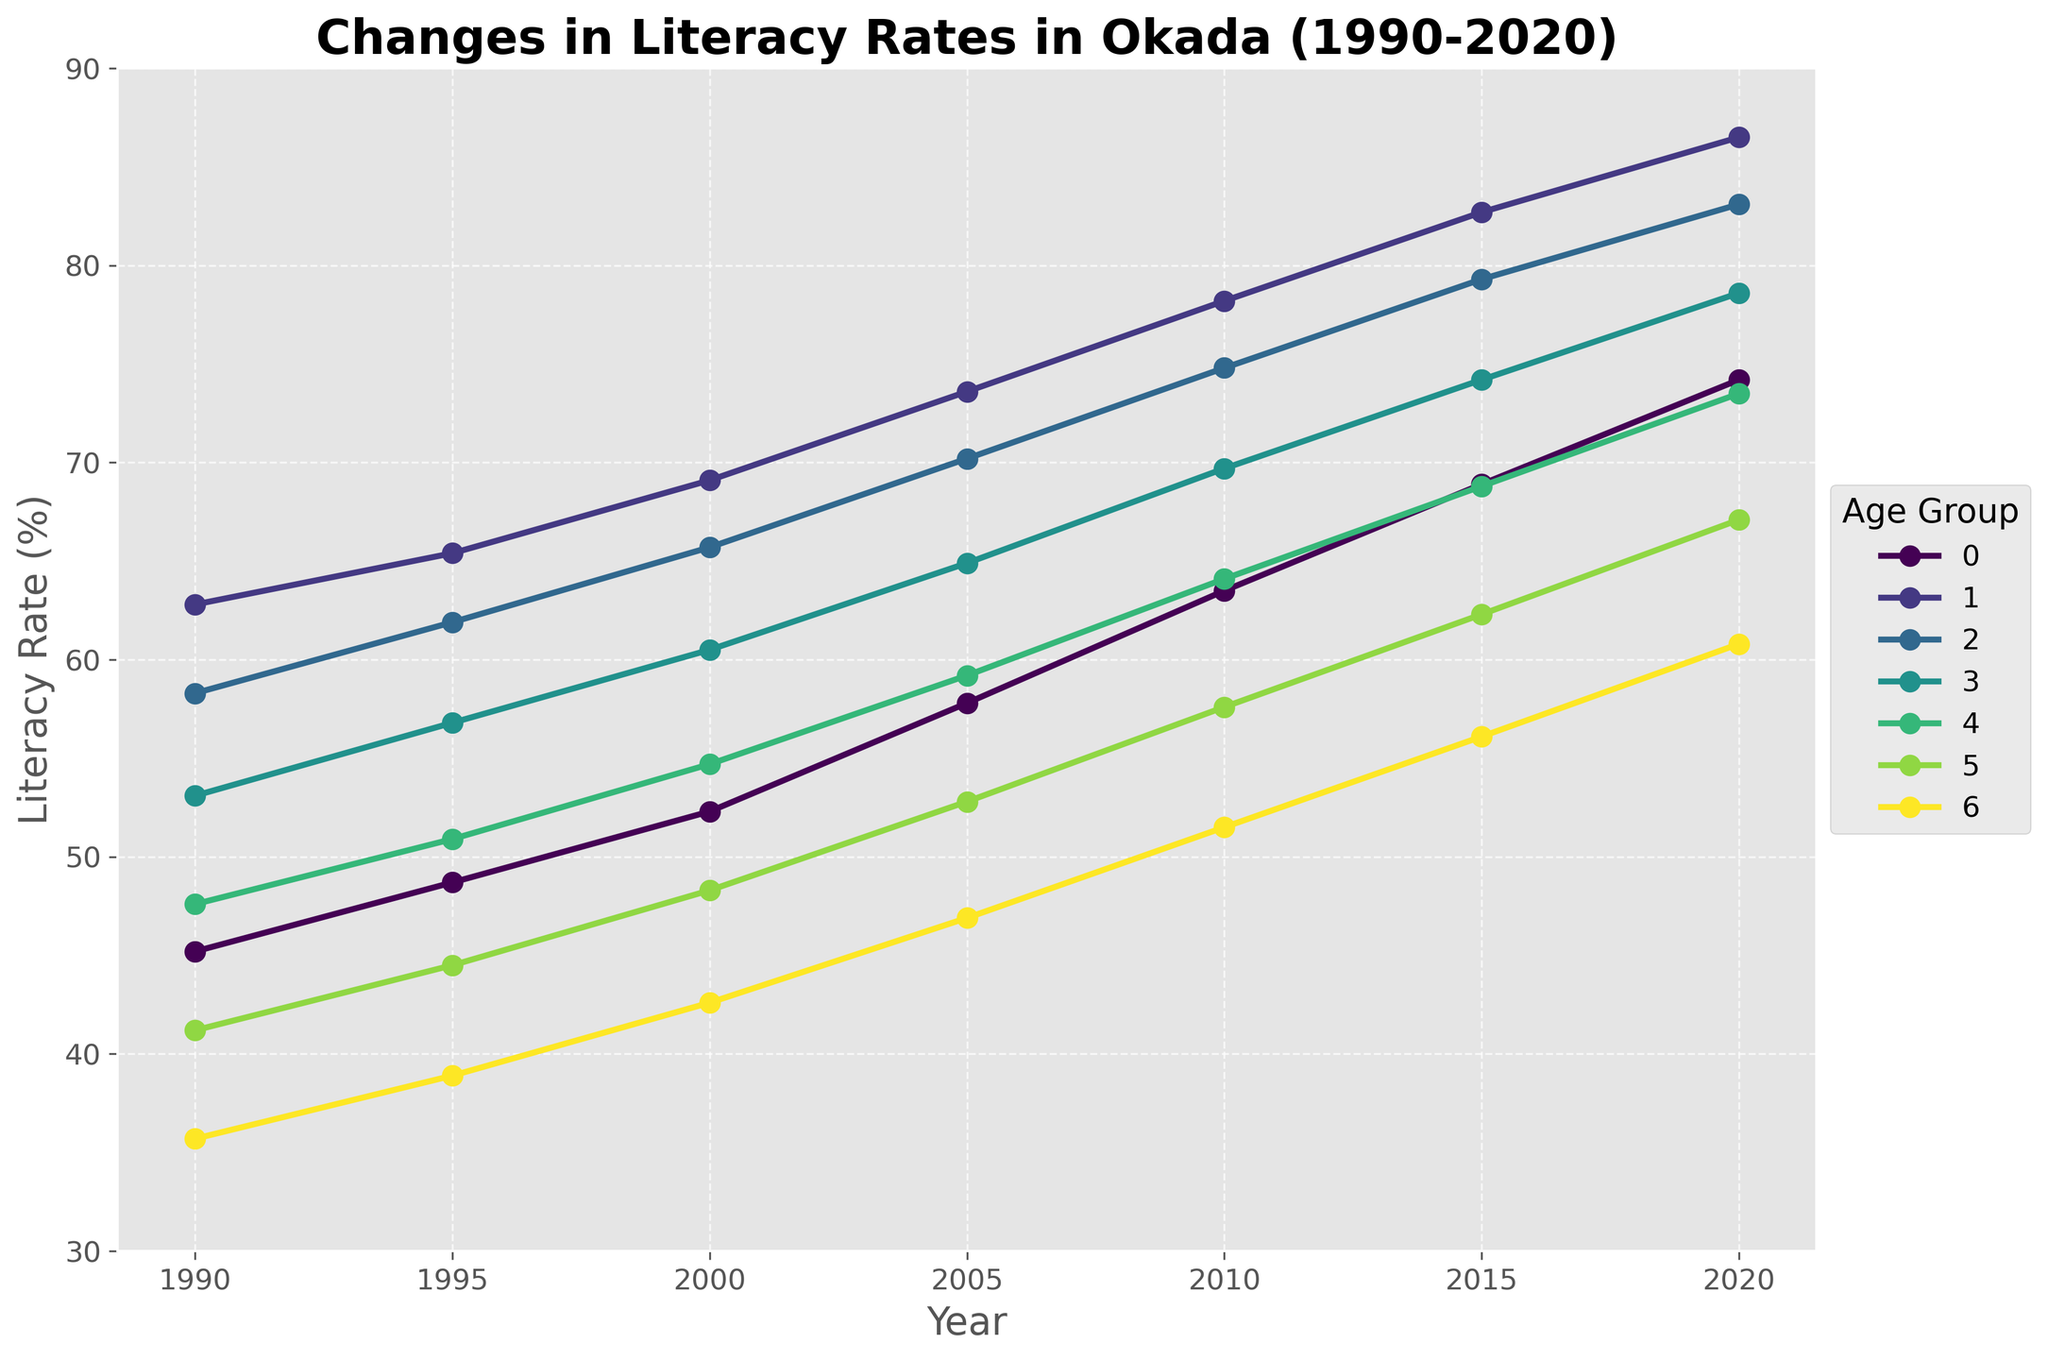What age group had the highest literacy rate in 2020? By looking at the data points for 2020, one can see that the age group 15-24 years has the highest literacy rate value compared to other age groups.
Answer: 15-24 years Which age group saw the largest increase in literacy rate from 1990 to 2020? To find the largest increase, subtract the 1990 value from the 2020 value for each age group and compare the differences. The age group 5-14 years had the largest increase (74.2 - 45.2 = 29).
Answer: 5-14 years What was the average literacy rate for the age group 25-34 years over the indicated years? Sum the literacy rates for the 25-34 years age group over all the years and divide by the number of years: (58.3 + 61.9 + 65.7 + 70.2 + 74.8 + 79.3 + 83.1) / 7 = 70.47.
Answer: 70.47 How does the literacy rate of the 65+ age group in 2000 compare to the 55-64 age group in 2000? Refer to the 2000 values; the literacy rate for 65+ years is 42.6, while for 55-64 years it is 48.3. This indicates that the 55-64 age group had a higher literacy rate in 2000.
Answer: The 55-64 age group had a higher rate By how much did the literacy rate for the 35-44 years age group increase from 2005 to 2015? Subtract the 2005 value from the 2015 value for the 35-44 years age group: 74.2 - 64.9 = 9.3.
Answer: 9.3 Which age group's literacy rate first fell below 50% and stayed above it in subsequent years? Look for the age group that had a literacy rate below 50% initially but stayed above 50% in subsequent years. The 45-54 years age group first fell below 50% in 1990 and stayed above 50% after that.
Answer: 45-54 years Does the literacy rate for the 15-24 years age group in 2010 exceed that of the 25-34 years age group in 2015? Compare the literacy rates: 15-24 years in 2010 is 78.2, and 25-34 years in 2015 is 79.3. The 25-34 years age group in 2015 exceeds the 15-24 years age group in 2010.
Answer: No What is the difference between the 1990 and 2020 literacy rates for the 55-64 years age group? Subtract the 1990 value from the 2020 value for the 55-64 years age group: 67.1 - 41.2 = 25.9.
Answer: 25.9 